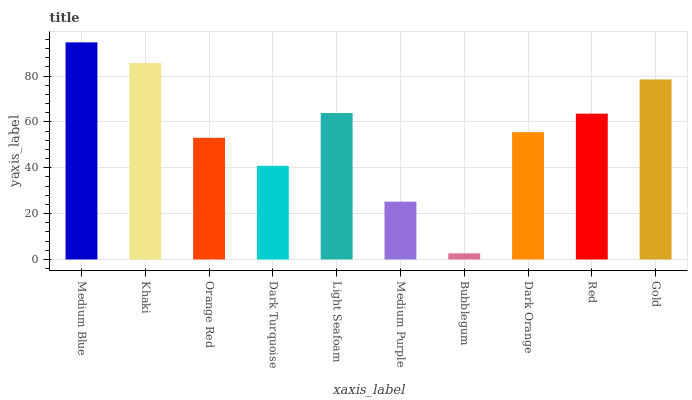Is Bubblegum the minimum?
Answer yes or no. Yes. Is Medium Blue the maximum?
Answer yes or no. Yes. Is Khaki the minimum?
Answer yes or no. No. Is Khaki the maximum?
Answer yes or no. No. Is Medium Blue greater than Khaki?
Answer yes or no. Yes. Is Khaki less than Medium Blue?
Answer yes or no. Yes. Is Khaki greater than Medium Blue?
Answer yes or no. No. Is Medium Blue less than Khaki?
Answer yes or no. No. Is Red the high median?
Answer yes or no. Yes. Is Dark Orange the low median?
Answer yes or no. Yes. Is Bubblegum the high median?
Answer yes or no. No. Is Dark Turquoise the low median?
Answer yes or no. No. 